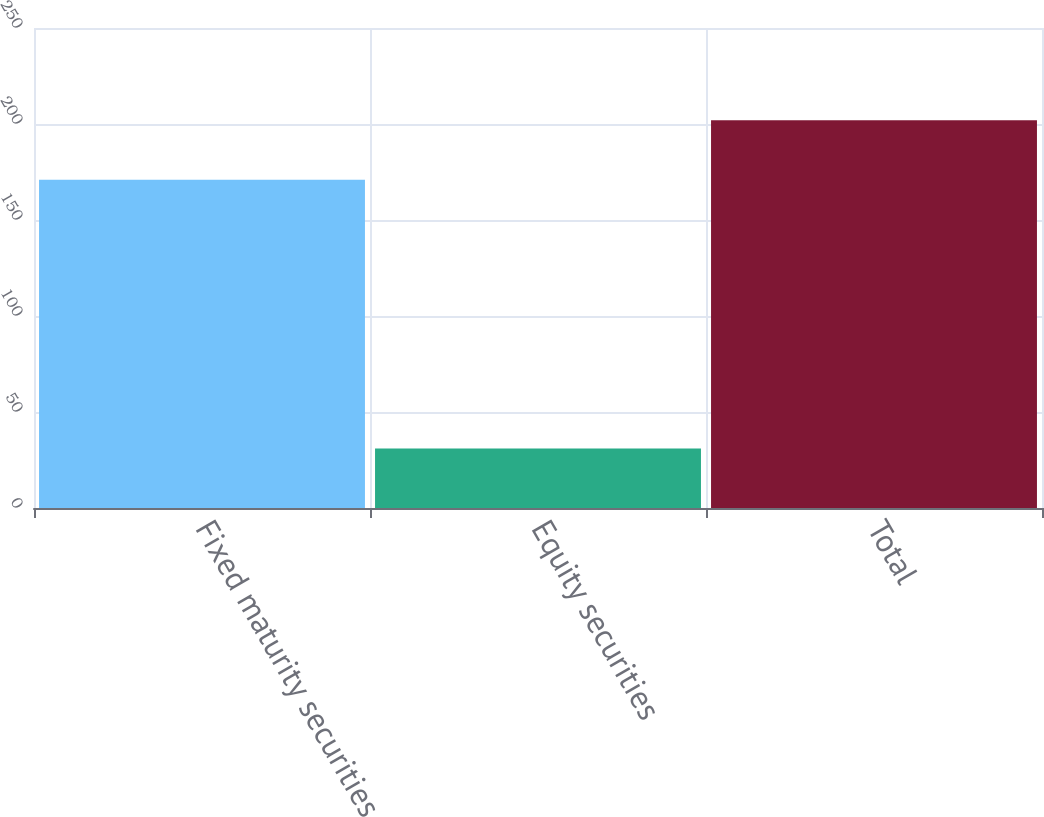Convert chart to OTSL. <chart><loc_0><loc_0><loc_500><loc_500><bar_chart><fcel>Fixed maturity securities<fcel>Equity securities<fcel>Total<nl><fcel>171<fcel>31<fcel>202<nl></chart> 